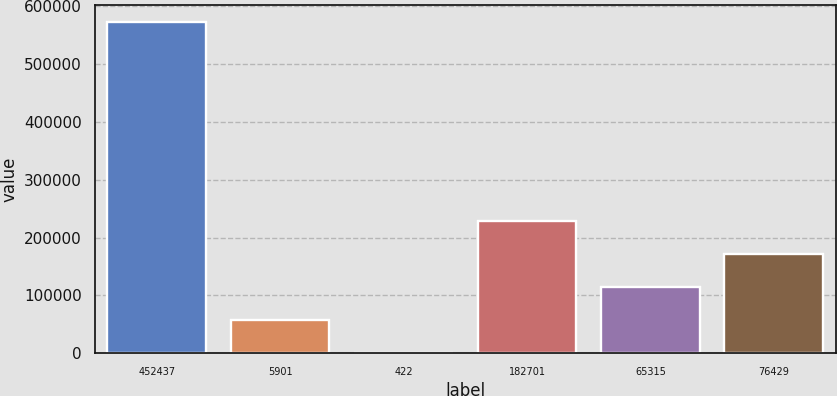Convert chart. <chart><loc_0><loc_0><loc_500><loc_500><bar_chart><fcel>452437<fcel>5901<fcel>422<fcel>182701<fcel>65315<fcel>76429<nl><fcel>572989<fcel>57779.5<fcel>534<fcel>229516<fcel>115025<fcel>172270<nl></chart> 